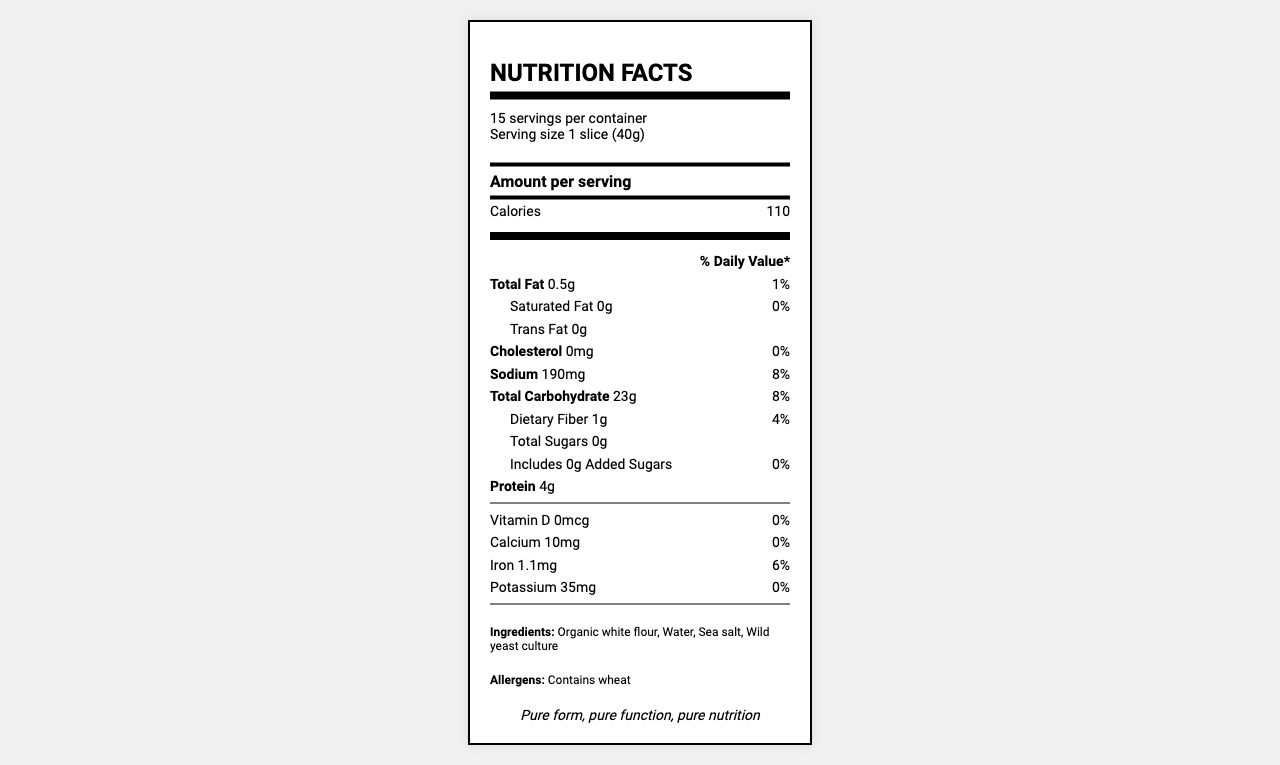what is the serving size? The serving size is prominently displayed near the top of the document, indicating 1 slice (40g).
Answer: 1 slice (40g) how many servings are per container? The document states that there are 15 servings per container.
Answer: 15 how many calories are there per serving? The calorie count per serving is shown directly next to the amount per serving.
Answer: 110 what percentage of daily value is the sodium content? The document specifies that the sodium content per serving makes up 8% of the daily value.
Answer: 8% what are the main ingredients in the bread? The ingredients are listed near the bottom of the document in the ingredients section.
Answer: Organic white flour, Water, Sea salt, Wild yeast culture how much protein does one serving contain? The document indicates that each serving contains 4g of protein.
Answer: 4g what is the total fat content per serving? The total fat content per serving is 0.5g, as mentioned in the nutritional facts.
Answer: 0.5g how much potassium is present in one serving? The document shows that there are 35mg of potassium per serving.
Answer: 35mg does the bread contain any added sugars? The document states that the bread has 0g of added sugars.
Answer: No is the packaging biodegradable? One of the sustainability features listed is biodegradable packaging.
Answer: Yes which of the following is NOT a Bauhaus design principle highlighted in the document? A. Simple, unadorned packaging B. Colorful illustrations C. Functional typography D. Monochromatic color scheme The options are given, and the document highlights "Simple, unadorned packaging," "Functional typography," and "Monochromatic color scheme" as Bauhaus design principles, thus making "Colorful illustrations" the correct answer.
Answer: B how much dietary fiber is in one serving of the bread? A. 0g B. 0.5g C. 1g D. 2g There is 1g of dietary fiber in one serving, as stated in the nutritional facts.
Answer: C does this bread contain cholesterol? The document states that the bread has 0mg of cholesterol.
Answer: No summarize the main idea of the document. The document's main idea revolves around offering essential nutritional information about the sourdough bread in a simple, clear, and aesthetically pleasing way, adhering to Bauhaus principles. It also focuses on sustainable and local ingredients.
Answer: The document provides a minimalist nutrition facts label for a pure white sourdough bread loaf, highlighting key nutritional information per serving, ingredients, allergens, Bauhaus design principles, and sustainability features. is the bread a good source of complex carbohydrates? One of the nutritional highlights mentioned is that the bread is a good source of complex carbohydrates.
Answer: Yes what is the percentage of daily value for saturated fat? The document indicates that the percentage of daily value for saturated fat is 0%.
Answer: 0% which ingredient is allergenic in the bread? The allergens section states that the bread contains wheat.
Answer: Wheat what is the amount of calcium in one serving? The document states that one serving contains 10mg of calcium.
Answer: 10mg are there any details about the bread's gluten content? The document does not mention the gluten content specifically.
Answer: Not enough information what is the brand’s statement regarding this bread? The brand statement at the bottom of the document reads: "Pure form, pure function, pure nutrition."
Answer: Pure form, pure function, pure nutrition 